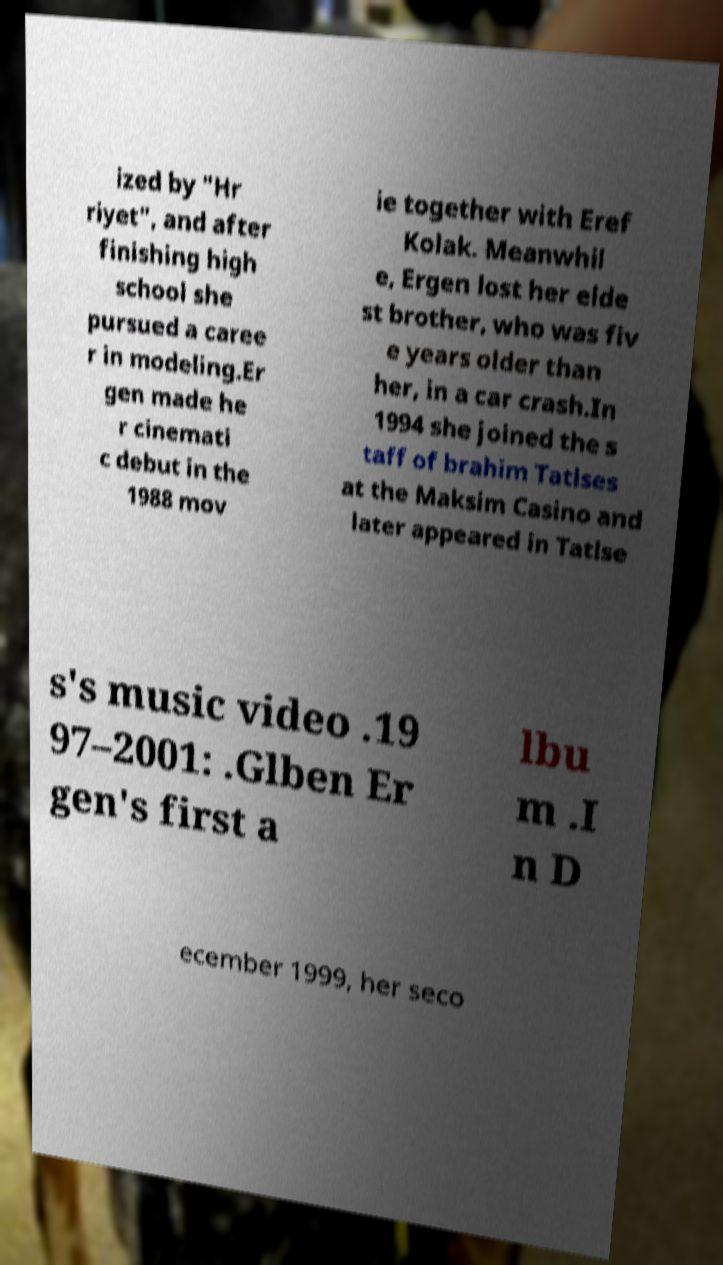There's text embedded in this image that I need extracted. Can you transcribe it verbatim? ized by "Hr riyet", and after finishing high school she pursued a caree r in modeling.Er gen made he r cinemati c debut in the 1988 mov ie together with Eref Kolak. Meanwhil e, Ergen lost her elde st brother, who was fiv e years older than her, in a car crash.In 1994 she joined the s taff of brahim Tatlses at the Maksim Casino and later appeared in Tatlse s's music video .19 97–2001: .Glben Er gen's first a lbu m .I n D ecember 1999, her seco 